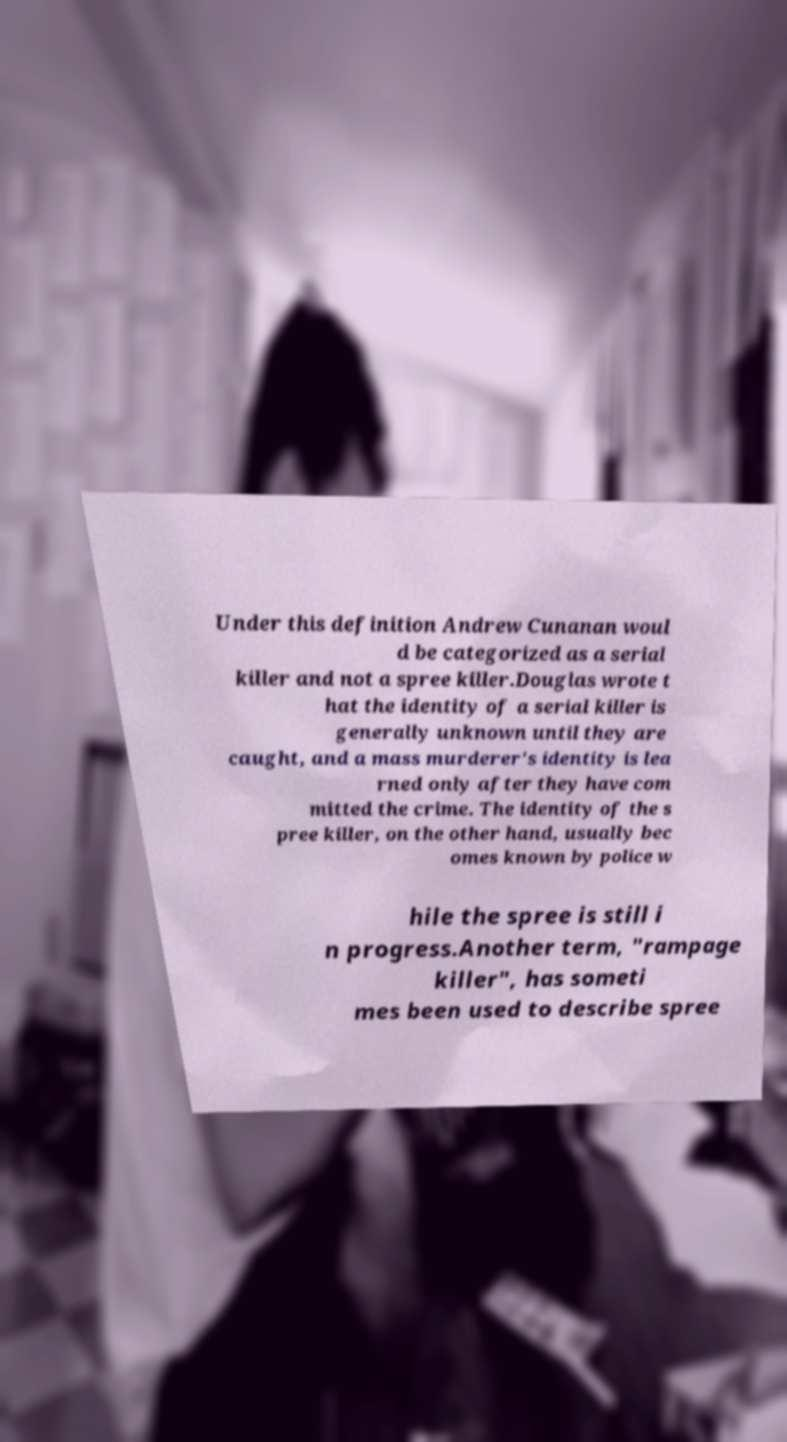I need the written content from this picture converted into text. Can you do that? Under this definition Andrew Cunanan woul d be categorized as a serial killer and not a spree killer.Douglas wrote t hat the identity of a serial killer is generally unknown until they are caught, and a mass murderer's identity is lea rned only after they have com mitted the crime. The identity of the s pree killer, on the other hand, usually bec omes known by police w hile the spree is still i n progress.Another term, "rampage killer", has someti mes been used to describe spree 